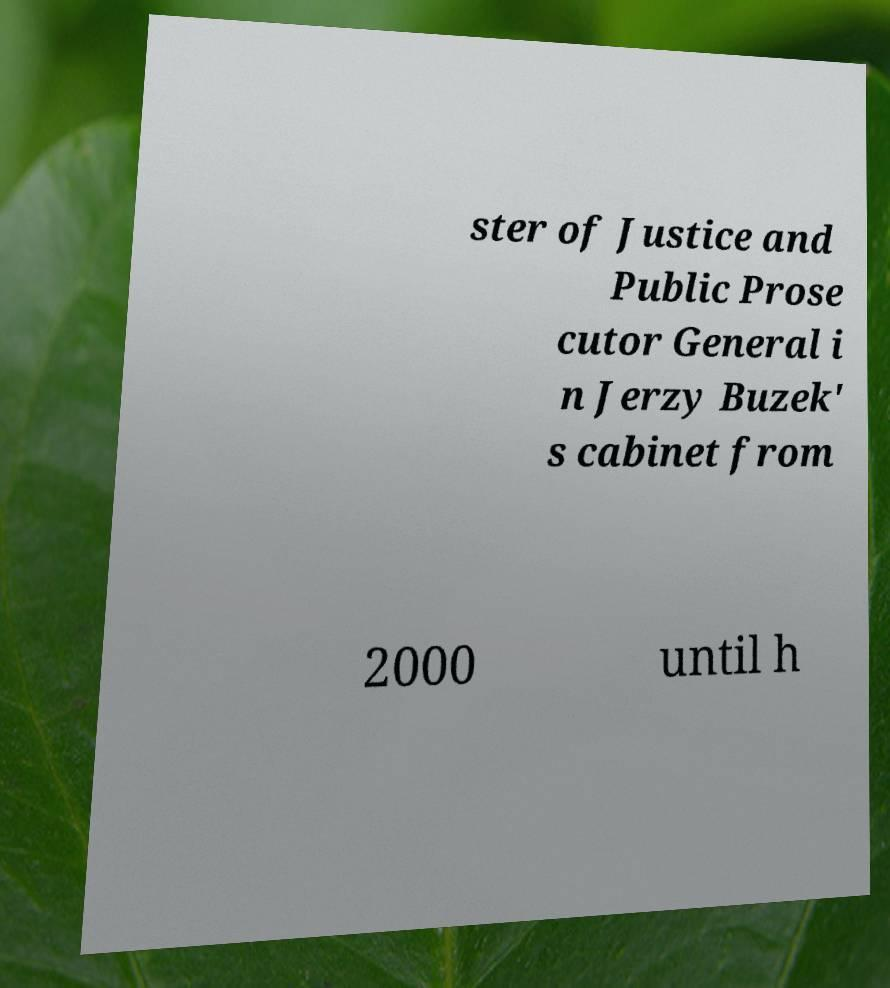There's text embedded in this image that I need extracted. Can you transcribe it verbatim? ster of Justice and Public Prose cutor General i n Jerzy Buzek' s cabinet from 2000 until h 